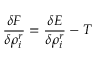<formula> <loc_0><loc_0><loc_500><loc_500>\frac { \delta F } { \delta \rho _ { i } ^ { r } } = \frac { \delta E } { \delta \rho _ { i } ^ { r } } - T</formula> 